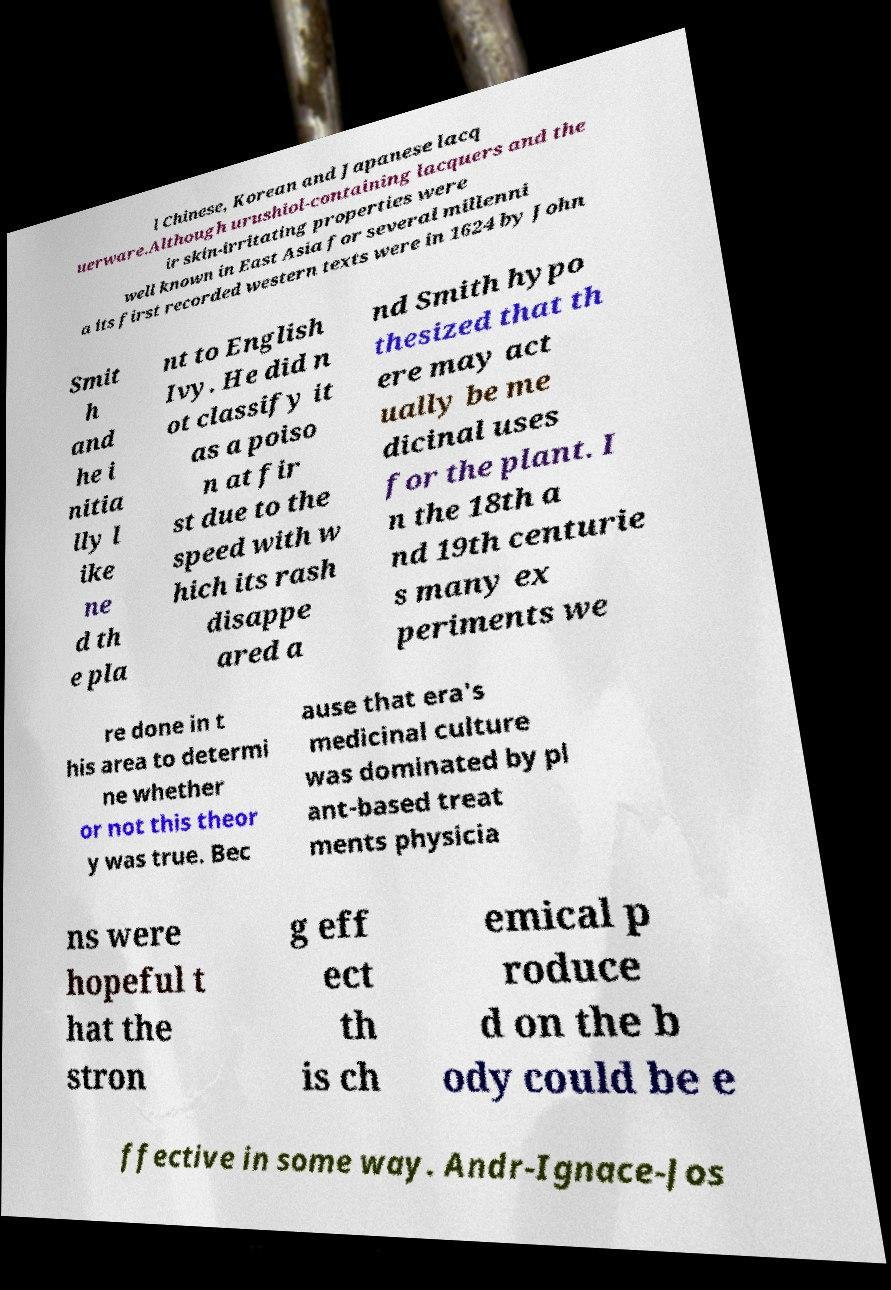Can you read and provide the text displayed in the image?This photo seems to have some interesting text. Can you extract and type it out for me? l Chinese, Korean and Japanese lacq uerware.Although urushiol-containing lacquers and the ir skin-irritating properties were well known in East Asia for several millenni a its first recorded western texts were in 1624 by John Smit h and he i nitia lly l ike ne d th e pla nt to English Ivy. He did n ot classify it as a poiso n at fir st due to the speed with w hich its rash disappe ared a nd Smith hypo thesized that th ere may act ually be me dicinal uses for the plant. I n the 18th a nd 19th centurie s many ex periments we re done in t his area to determi ne whether or not this theor y was true. Bec ause that era's medicinal culture was dominated by pl ant-based treat ments physicia ns were hopeful t hat the stron g eff ect th is ch emical p roduce d on the b ody could be e ffective in some way. Andr-Ignace-Jos 